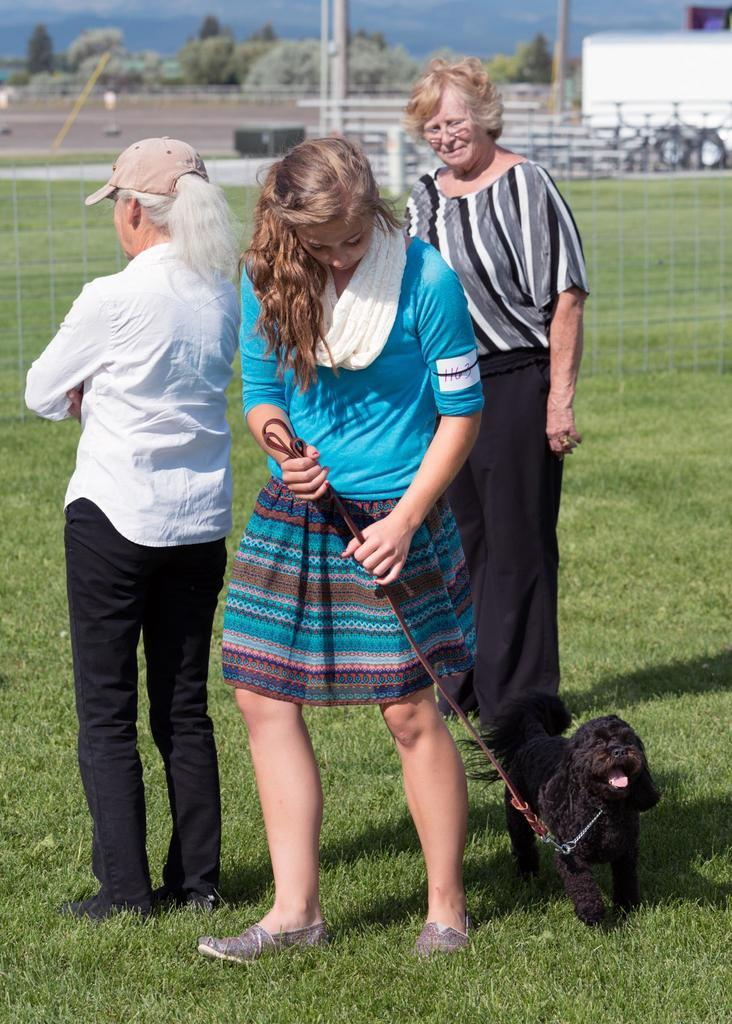How many women are in the image? There are three women in the image. What is the setting of the image? The women are standing on a green field. What is the woman holding in the image? One woman is holding a dog with a string. What can be seen in the background of the image? There are trees visible in the image. What type of rock is the woman wearing as a locket in the image? There is no rock or locket present in the image. What type of leather is the dog wearing in the image? There is no dog wearing leather in the image; the dog is held by a string. 